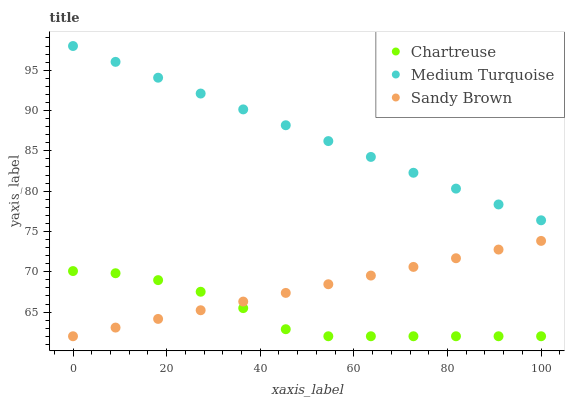Does Chartreuse have the minimum area under the curve?
Answer yes or no. Yes. Does Medium Turquoise have the maximum area under the curve?
Answer yes or no. Yes. Does Sandy Brown have the minimum area under the curve?
Answer yes or no. No. Does Sandy Brown have the maximum area under the curve?
Answer yes or no. No. Is Sandy Brown the smoothest?
Answer yes or no. Yes. Is Chartreuse the roughest?
Answer yes or no. Yes. Is Medium Turquoise the smoothest?
Answer yes or no. No. Is Medium Turquoise the roughest?
Answer yes or no. No. Does Chartreuse have the lowest value?
Answer yes or no. Yes. Does Medium Turquoise have the lowest value?
Answer yes or no. No. Does Medium Turquoise have the highest value?
Answer yes or no. Yes. Does Sandy Brown have the highest value?
Answer yes or no. No. Is Sandy Brown less than Medium Turquoise?
Answer yes or no. Yes. Is Medium Turquoise greater than Sandy Brown?
Answer yes or no. Yes. Does Sandy Brown intersect Chartreuse?
Answer yes or no. Yes. Is Sandy Brown less than Chartreuse?
Answer yes or no. No. Is Sandy Brown greater than Chartreuse?
Answer yes or no. No. Does Sandy Brown intersect Medium Turquoise?
Answer yes or no. No. 